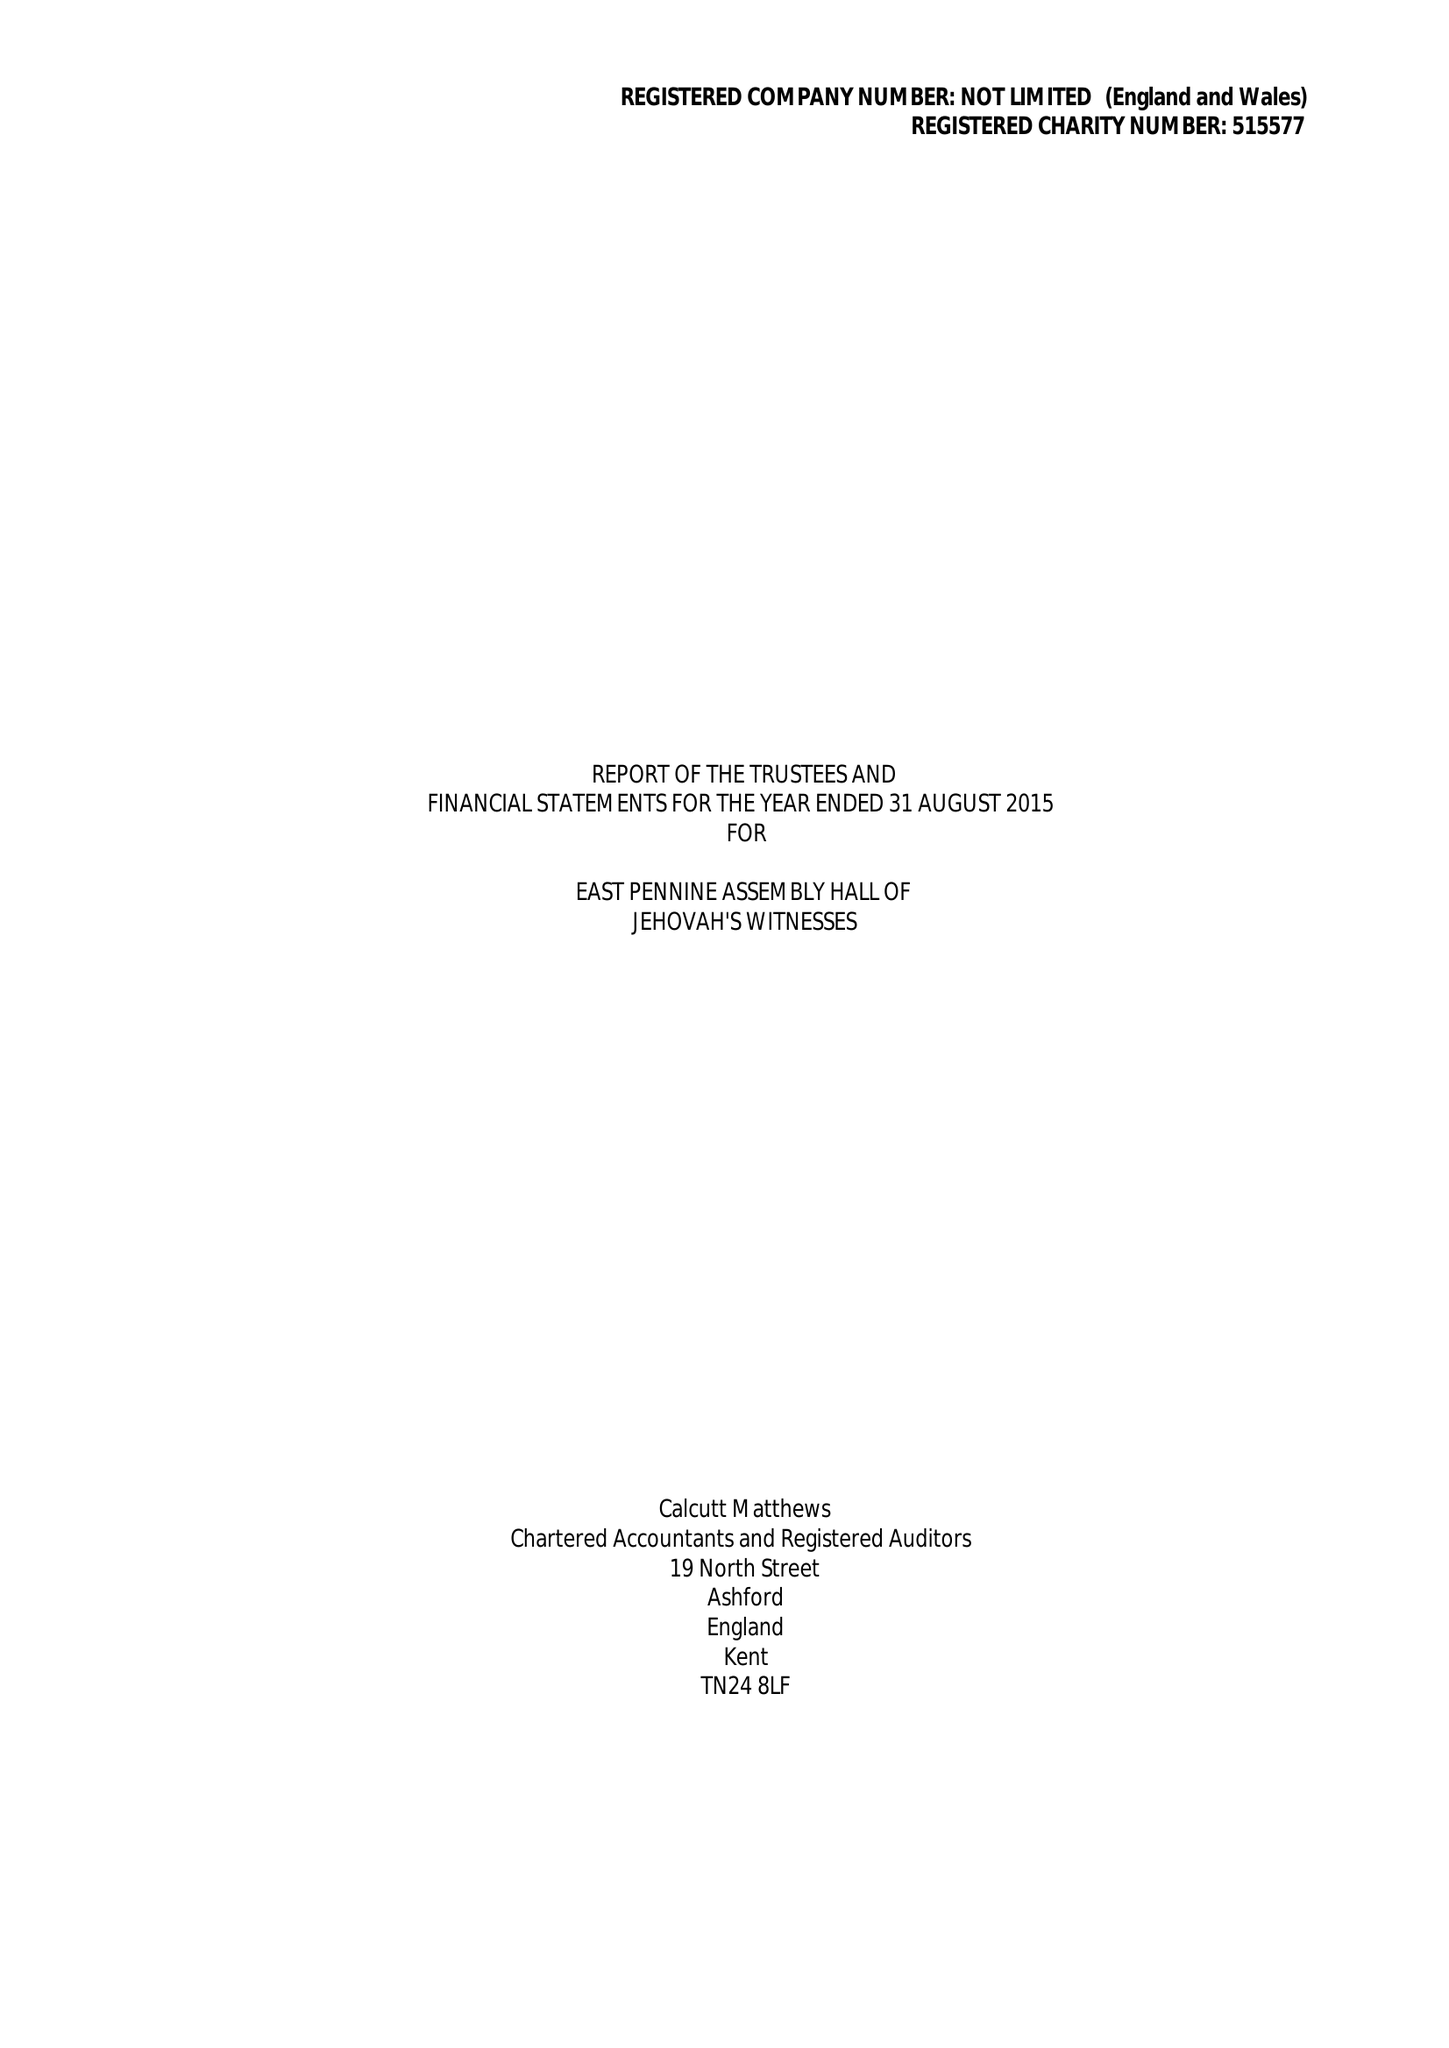What is the value for the charity_number?
Answer the question using a single word or phrase. 515577 